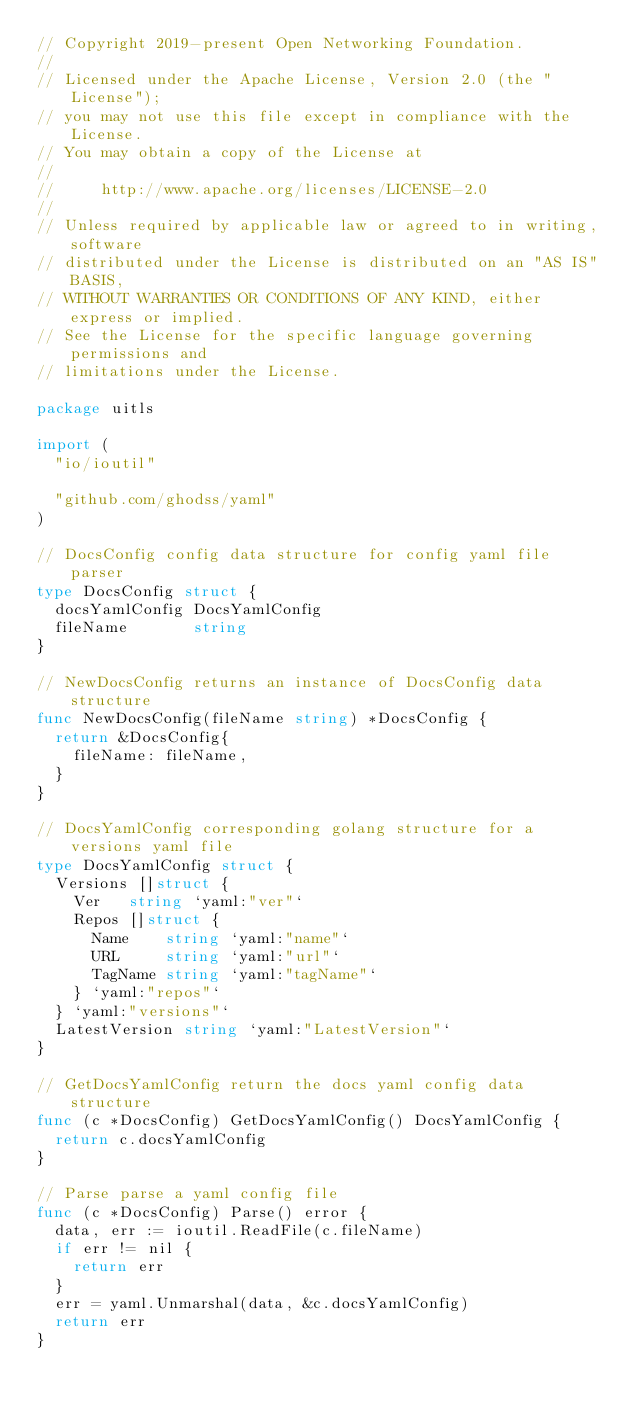<code> <loc_0><loc_0><loc_500><loc_500><_Go_>// Copyright 2019-present Open Networking Foundation.
//
// Licensed under the Apache License, Version 2.0 (the "License");
// you may not use this file except in compliance with the License.
// You may obtain a copy of the License at
//
//     http://www.apache.org/licenses/LICENSE-2.0
//
// Unless required by applicable law or agreed to in writing, software
// distributed under the License is distributed on an "AS IS" BASIS,
// WITHOUT WARRANTIES OR CONDITIONS OF ANY KIND, either express or implied.
// See the License for the specific language governing permissions and
// limitations under the License.

package uitls

import (
	"io/ioutil"

	"github.com/ghodss/yaml"
)

// DocsConfig config data structure for config yaml file parser
type DocsConfig struct {
	docsYamlConfig DocsYamlConfig
	fileName       string
}

// NewDocsConfig returns an instance of DocsConfig data structure
func NewDocsConfig(fileName string) *DocsConfig {
	return &DocsConfig{
		fileName: fileName,
	}
}

// DocsYamlConfig corresponding golang structure for a versions yaml file
type DocsYamlConfig struct {
	Versions []struct {
		Ver   string `yaml:"ver"`
		Repos []struct {
			Name    string `yaml:"name"`
			URL     string `yaml:"url"`
			TagName string `yaml:"tagName"`
		} `yaml:"repos"`
	} `yaml:"versions"`
	LatestVersion string `yaml:"LatestVersion"`
}

// GetDocsYamlConfig return the docs yaml config data structure
func (c *DocsConfig) GetDocsYamlConfig() DocsYamlConfig {
	return c.docsYamlConfig
}

// Parse parse a yaml config file
func (c *DocsConfig) Parse() error {
	data, err := ioutil.ReadFile(c.fileName)
	if err != nil {
		return err
	}
	err = yaml.Unmarshal(data, &c.docsYamlConfig)
	return err
}
</code> 